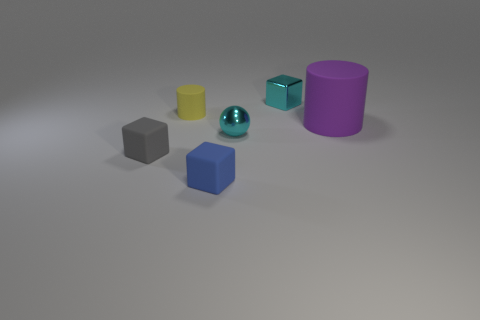Subtract all cyan metal blocks. How many blocks are left? 2 Subtract 1 cubes. How many cubes are left? 2 Add 1 metallic things. How many objects exist? 7 Subtract all cylinders. How many objects are left? 4 Subtract all yellow blocks. Subtract all brown balls. How many blocks are left? 3 Subtract 0 gray spheres. How many objects are left? 6 Subtract all big yellow cubes. Subtract all cylinders. How many objects are left? 4 Add 3 tiny rubber objects. How many tiny rubber objects are left? 6 Add 2 red blocks. How many red blocks exist? 2 